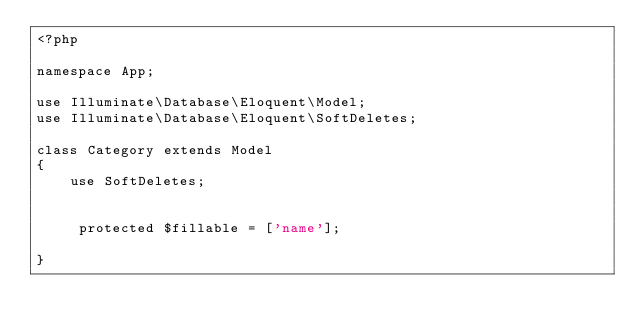Convert code to text. <code><loc_0><loc_0><loc_500><loc_500><_PHP_><?php

namespace App;

use Illuminate\Database\Eloquent\Model;
use Illuminate\Database\Eloquent\SoftDeletes;

class Category extends Model
{
    use SoftDeletes;


     protected $fillable = ['name'];

}
</code> 